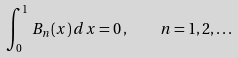Convert formula to latex. <formula><loc_0><loc_0><loc_500><loc_500>\int _ { 0 } ^ { 1 } \, B _ { n } ( x ) \, d x = 0 \, , \quad n = 1 , 2 , \dots</formula> 